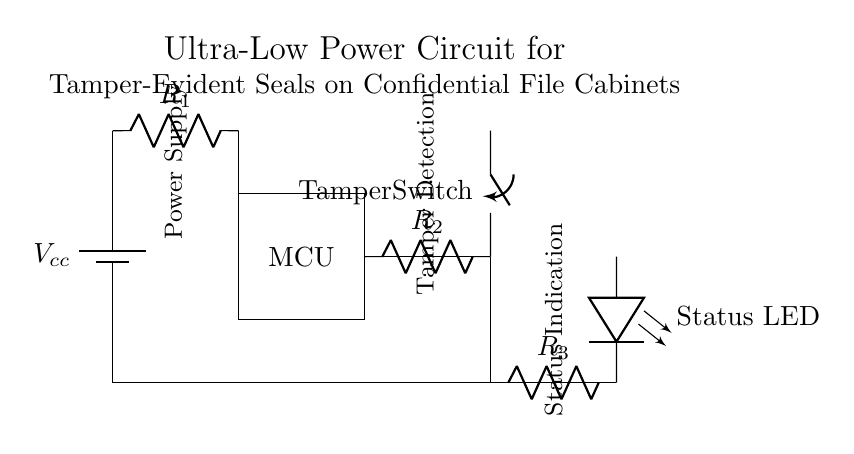What is the type of the power source? The power source shown is a battery, as indicated by the symbol and label (Vcc). It provides the necessary voltage for the circuit to operate.
Answer: Battery What is the role of the tamper switch? The tamper switch is designed to detect unauthorized access or tampering, acting as a safeguard to trigger the LED indicator when the cabinet is opened or breached.
Answer: Detection How many resistors are in the circuit? There are three resistors labeled R1, R2, and R3, which are used for current limiting and voltage division in the circuit.
Answer: Three What does the LED indicate? The LED serves as a status indicator, lighting up when the tamper switch detects an intrusion or when the circuit is powered on, providing visual feedback.
Answer: Status How is the microcontroller powered? The microcontroller is powered from the battery indirectly through the resistors, which help manage the voltage and current supplied to it.
Answer: Battery What is the main function of the microcontroller in this circuit? The microcontroller processes the signal from the tamper switch and controls the status LED, functioning as the central processing unit of the circuit.
Answer: Processing What type of circuit is this? This is an ultra-low power circuit specifically designed for a tamper-evident seal application, balancing minimal energy consumption with effective tamper detection.
Answer: Low Power 